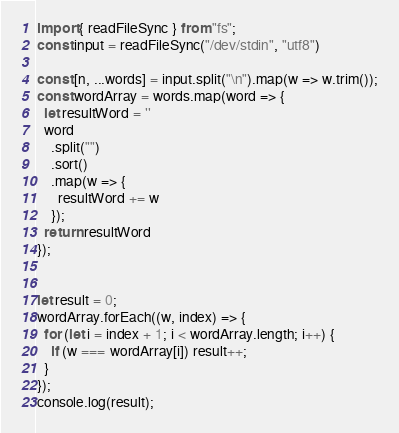Convert code to text. <code><loc_0><loc_0><loc_500><loc_500><_TypeScript_>import { readFileSync } from "fs";
const input = readFileSync("/dev/stdin", "utf8")

const [n, ...words] = input.split("\n").map(w => w.trim());
const wordArray = words.map(word => {
  let resultWord = ''
  word
    .split("")
    .sort()
    .map(w => {
      resultWord += w
    });
  return resultWord
});


let result = 0;
wordArray.forEach((w, index) => {
  for (let i = index + 1; i < wordArray.length; i++) {
    if (w === wordArray[i]) result++;
  }
});
console.log(result);</code> 